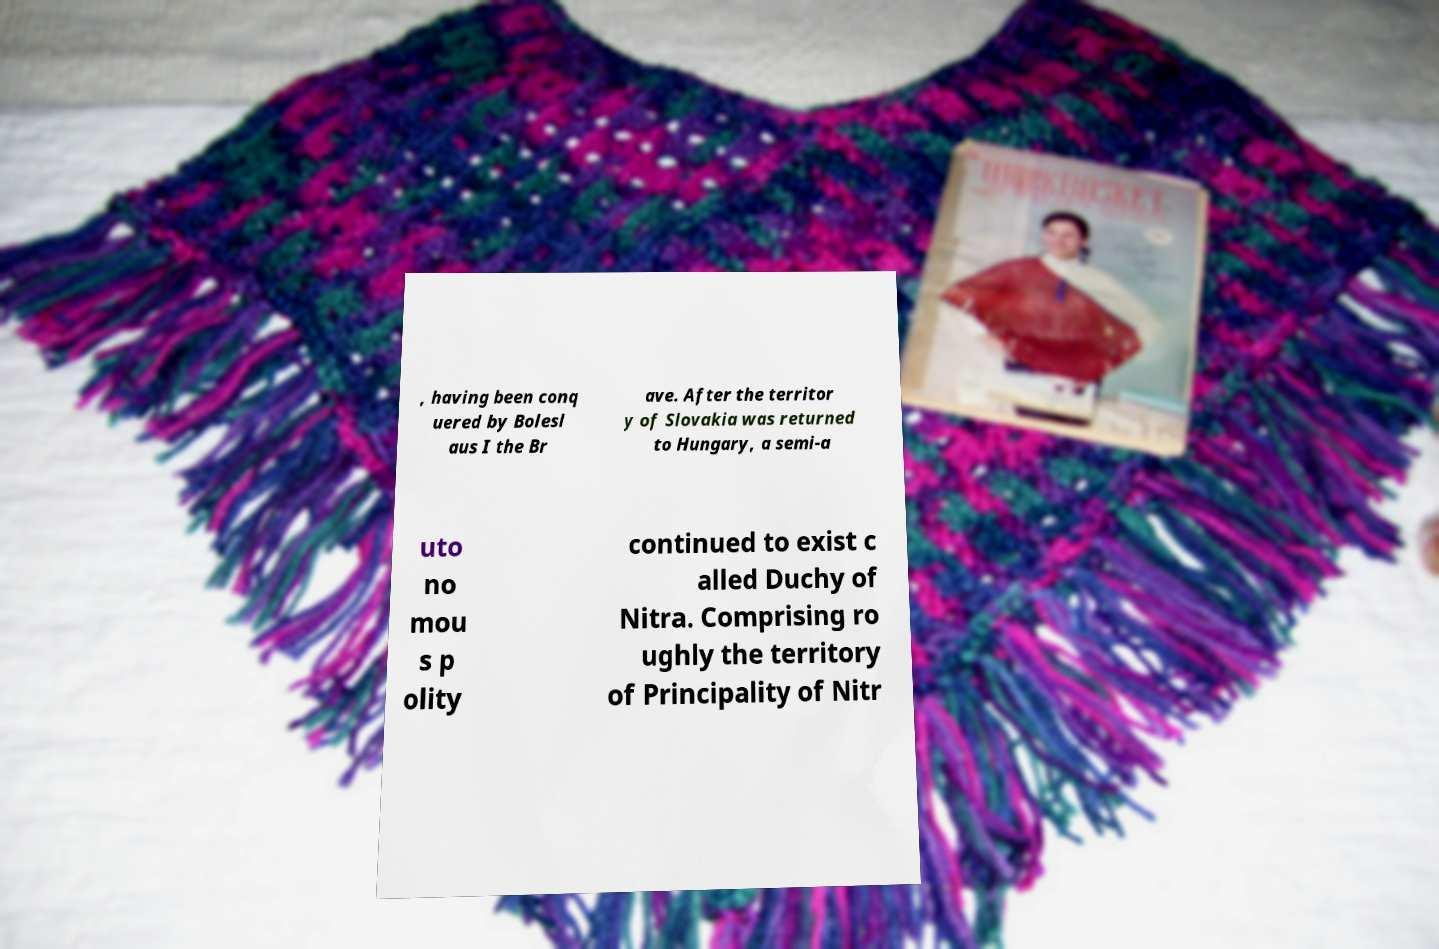Please identify and transcribe the text found in this image. , having been conq uered by Bolesl aus I the Br ave. After the territor y of Slovakia was returned to Hungary, a semi-a uto no mou s p olity continued to exist c alled Duchy of Nitra. Comprising ro ughly the territory of Principality of Nitr 